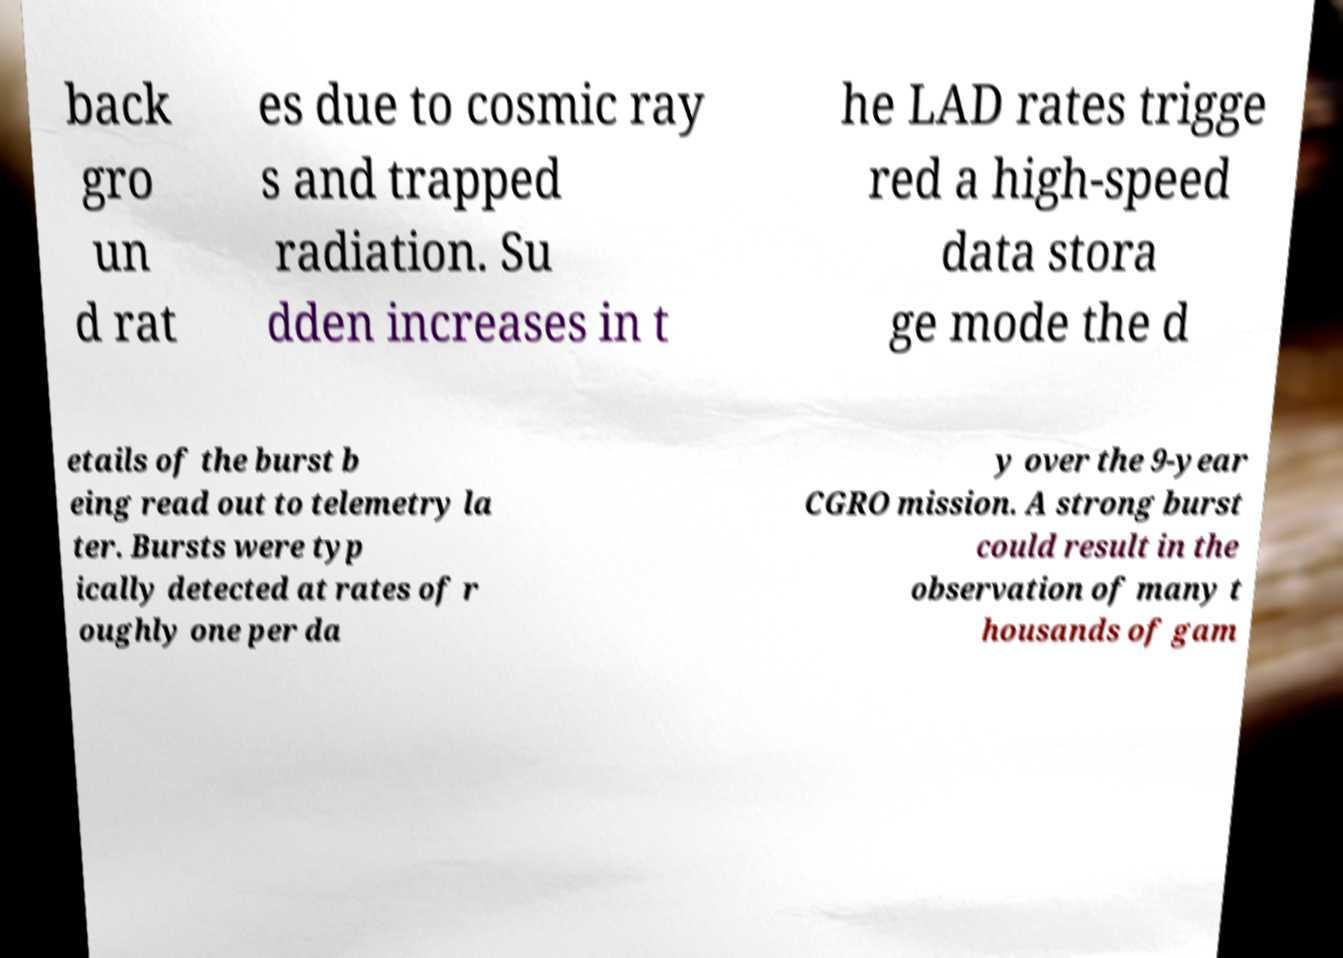For documentation purposes, I need the text within this image transcribed. Could you provide that? back gro un d rat es due to cosmic ray s and trapped radiation. Su dden increases in t he LAD rates trigge red a high-speed data stora ge mode the d etails of the burst b eing read out to telemetry la ter. Bursts were typ ically detected at rates of r oughly one per da y over the 9-year CGRO mission. A strong burst could result in the observation of many t housands of gam 